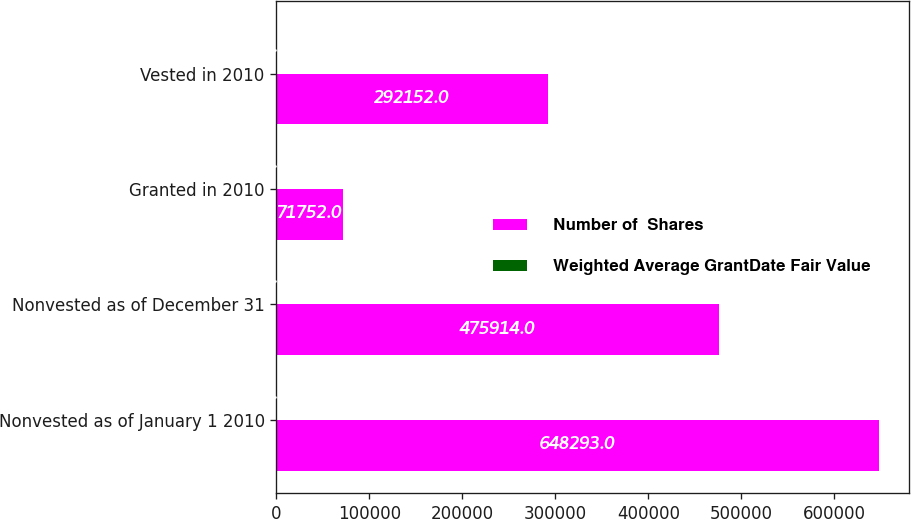Convert chart to OTSL. <chart><loc_0><loc_0><loc_500><loc_500><stacked_bar_chart><ecel><fcel>Nonvested as of January 1 2010<fcel>Nonvested as of December 31<fcel>Granted in 2010<fcel>Vested in 2010<nl><fcel>Number of  Shares<fcel>648293<fcel>475914<fcel>71752<fcel>292152<nl><fcel>Weighted Average GrantDate Fair Value<fcel>50.39<fcel>51.26<fcel>38.43<fcel>38.75<nl></chart> 